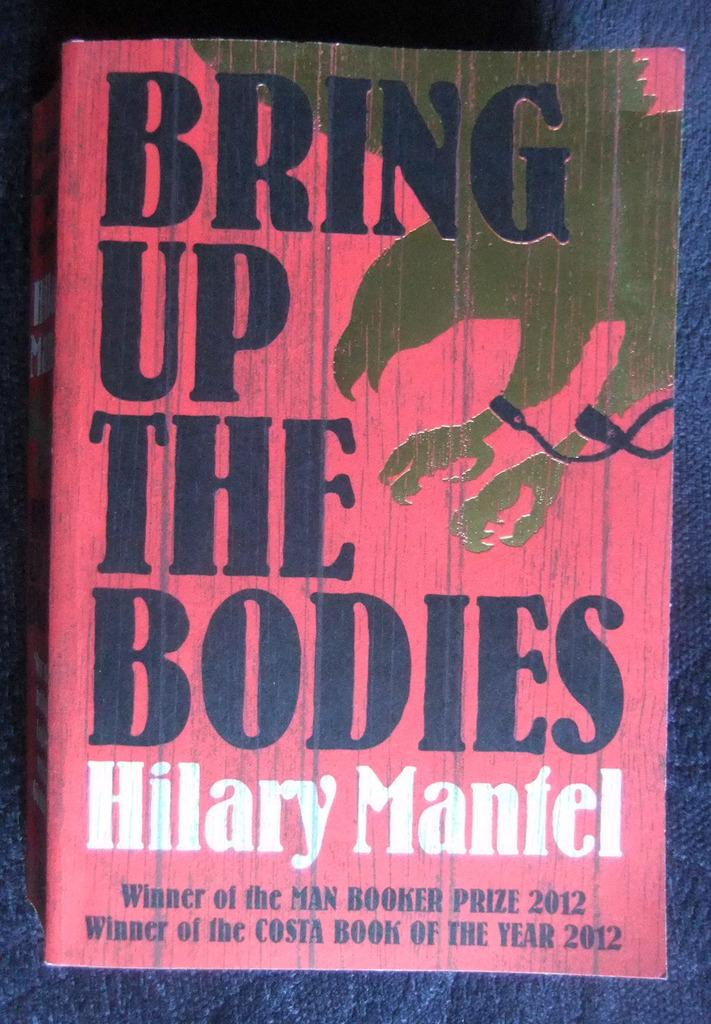What is depicted on the book cover in the image? The book cover has the title "Bring Up the Bodies." What color is the book cover in the image? The book cover is pink in color. Where is the toothbrush and paste located in the image? There is no toothbrush or paste present in the image; it only features a book cover. 